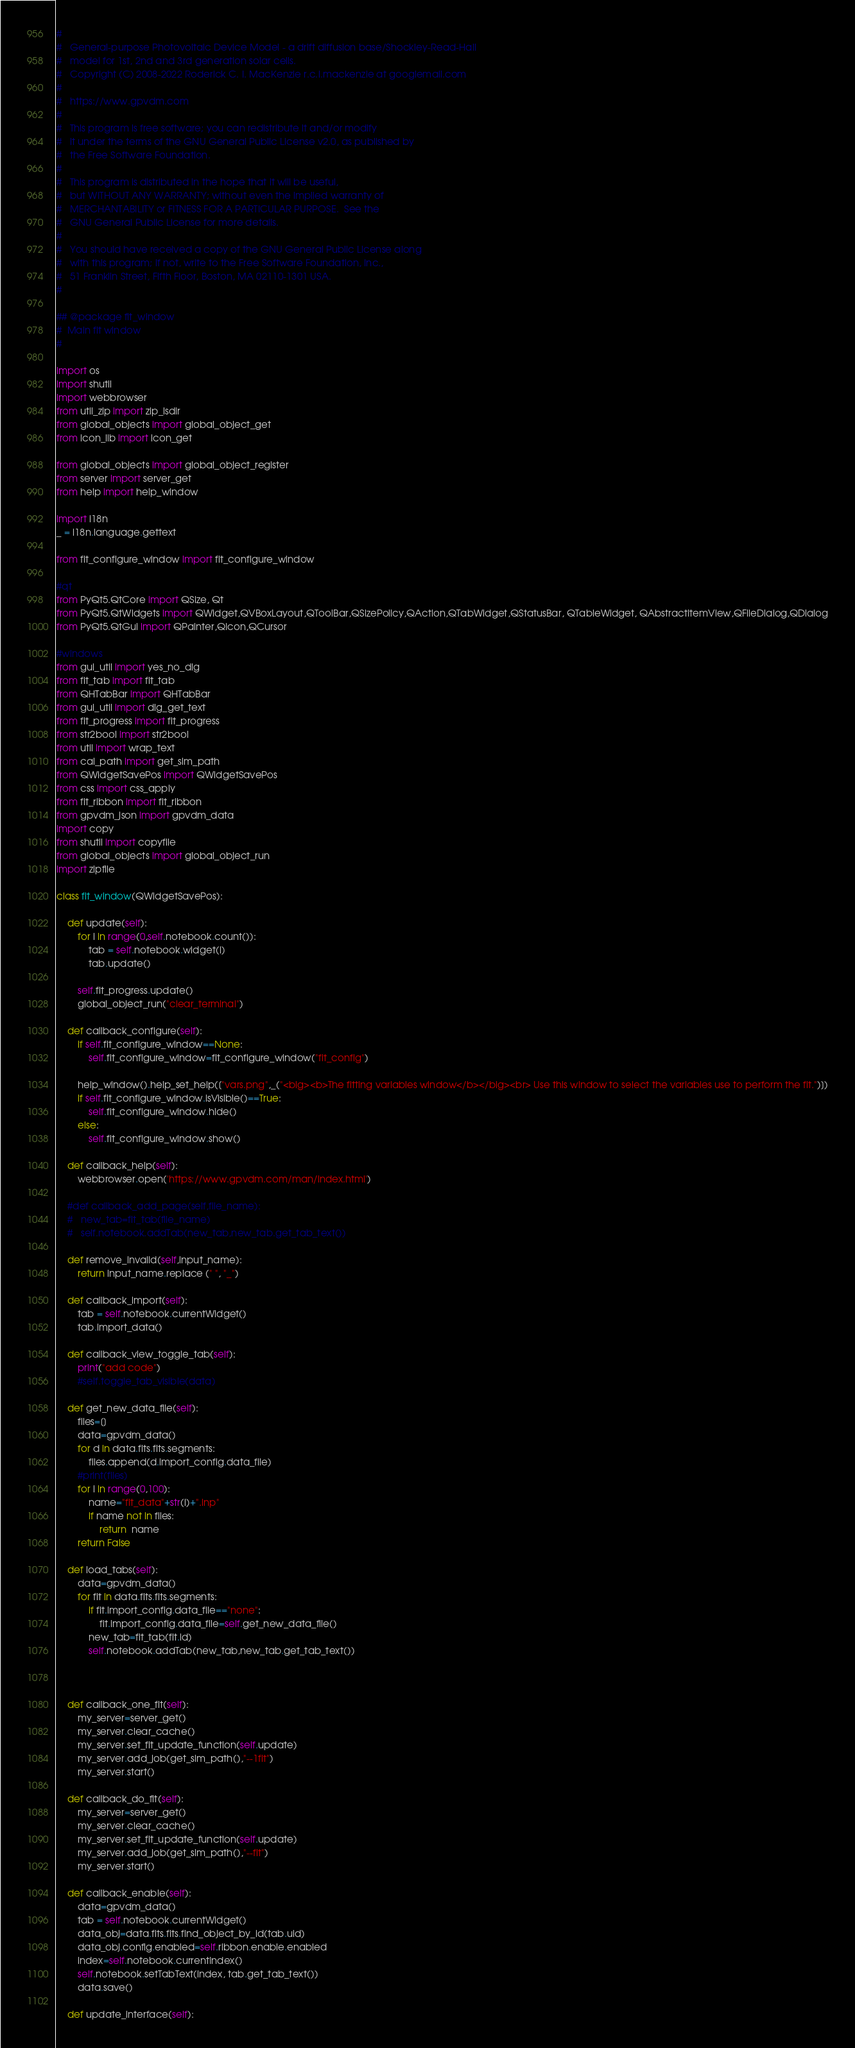<code> <loc_0><loc_0><loc_500><loc_500><_Python_>#
#   General-purpose Photovoltaic Device Model - a drift diffusion base/Shockley-Read-Hall
#   model for 1st, 2nd and 3rd generation solar cells.
#   Copyright (C) 2008-2022 Roderick C. I. MacKenzie r.c.i.mackenzie at googlemail.com
#   
#   https://www.gpvdm.com
#   
#   This program is free software; you can redistribute it and/or modify
#   it under the terms of the GNU General Public License v2.0, as published by
#   the Free Software Foundation.
#   
#   This program is distributed in the hope that it will be useful,
#   but WITHOUT ANY WARRANTY; without even the implied warranty of
#   MERCHANTABILITY or FITNESS FOR A PARTICULAR PURPOSE.  See the
#   GNU General Public License for more details.
#   
#   You should have received a copy of the GNU General Public License along
#   with this program; if not, write to the Free Software Foundation, Inc.,
#   51 Franklin Street, Fifth Floor, Boston, MA 02110-1301 USA.
#   

## @package fit_window
#  Main fit window
#

import os
import shutil
import webbrowser
from util_zip import zip_lsdir
from global_objects import global_object_get
from icon_lib import icon_get

from global_objects import global_object_register
from server import server_get
from help import help_window

import i18n
_ = i18n.language.gettext

from fit_configure_window import fit_configure_window

#qt
from PyQt5.QtCore import QSize, Qt
from PyQt5.QtWidgets import QWidget,QVBoxLayout,QToolBar,QSizePolicy,QAction,QTabWidget,QStatusBar, QTableWidget, QAbstractItemView,QFileDialog,QDialog
from PyQt5.QtGui import QPainter,QIcon,QCursor

#windows
from gui_util import yes_no_dlg
from fit_tab import fit_tab
from QHTabBar import QHTabBar
from gui_util import dlg_get_text
from fit_progress import fit_progress
from str2bool import str2bool
from util import wrap_text
from cal_path import get_sim_path
from QWidgetSavePos import QWidgetSavePos
from css import css_apply
from fit_ribbon import fit_ribbon
from gpvdm_json import gpvdm_data
import copy
from shutil import copyfile
from global_objects import global_object_run
import zipfile

class fit_window(QWidgetSavePos):

	def update(self):
		for i in range(0,self.notebook.count()):
			tab = self.notebook.widget(i)
			tab.update()

		self.fit_progress.update()
		global_object_run("clear_terminal")

	def callback_configure(self):
		if self.fit_configure_window==None:
			self.fit_configure_window=fit_configure_window("fit_config")

		help_window().help_set_help(["vars.png",_("<big><b>The fitting variables window</b></big><br> Use this window to select the variables use to perform the fit.")])
		if self.fit_configure_window.isVisible()==True:
			self.fit_configure_window.hide()
		else:
			self.fit_configure_window.show()

	def callback_help(self):
		webbrowser.open('https://www.gpvdm.com/man/index.html')

	#def callback_add_page(self,file_name):
	#	new_tab=fit_tab(file_name)
	#	self.notebook.addTab(new_tab,new_tab.get_tab_text())

	def remove_invalid(self,input_name):
		return input_name.replace (" ", "_")

	def callback_import(self):
		tab = self.notebook.currentWidget()
		tab.import_data()

	def callback_view_toggle_tab(self):
		print("add code")
		#self.toggle_tab_visible(data)

	def get_new_data_file(self):
		files=[]
		data=gpvdm_data()
		for d in data.fits.fits.segments:
			files.append(d.import_config.data_file)
		#print(files)
		for i in range(0,100):
			name="fit_data"+str(i)+".inp"
			if name not in files:
				return  name
		return False

	def load_tabs(self):
		data=gpvdm_data()
		for fit in data.fits.fits.segments:
			if fit.import_config.data_file=="none":
				fit.import_config.data_file=self.get_new_data_file()
			new_tab=fit_tab(fit.id)
			self.notebook.addTab(new_tab,new_tab.get_tab_text())



	def callback_one_fit(self):
		my_server=server_get()
		my_server.clear_cache()
		my_server.set_fit_update_function(self.update)
		my_server.add_job(get_sim_path(),"--1fit")
		my_server.start()

	def callback_do_fit(self):
		my_server=server_get()
		my_server.clear_cache()
		my_server.set_fit_update_function(self.update)
		my_server.add_job(get_sim_path(),"--fit")
		my_server.start()

	def callback_enable(self):
		data=gpvdm_data()
		tab = self.notebook.currentWidget()
		data_obj=data.fits.fits.find_object_by_id(tab.uid)
		data_obj.config.enabled=self.ribbon.enable.enabled
		index=self.notebook.currentIndex()
		self.notebook.setTabText(index, tab.get_tab_text())
		data.save()

	def update_interface(self):</code> 